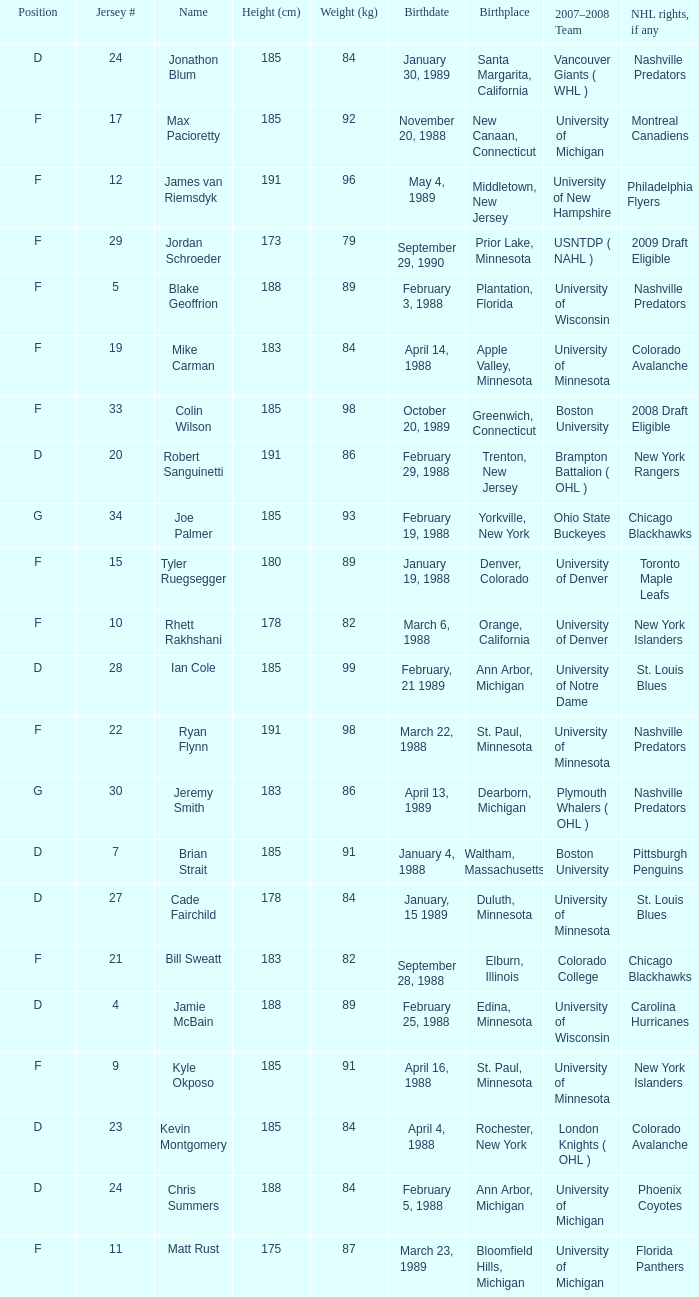Which Height (cm) has a Birthplace of new canaan, connecticut? 1.0. 